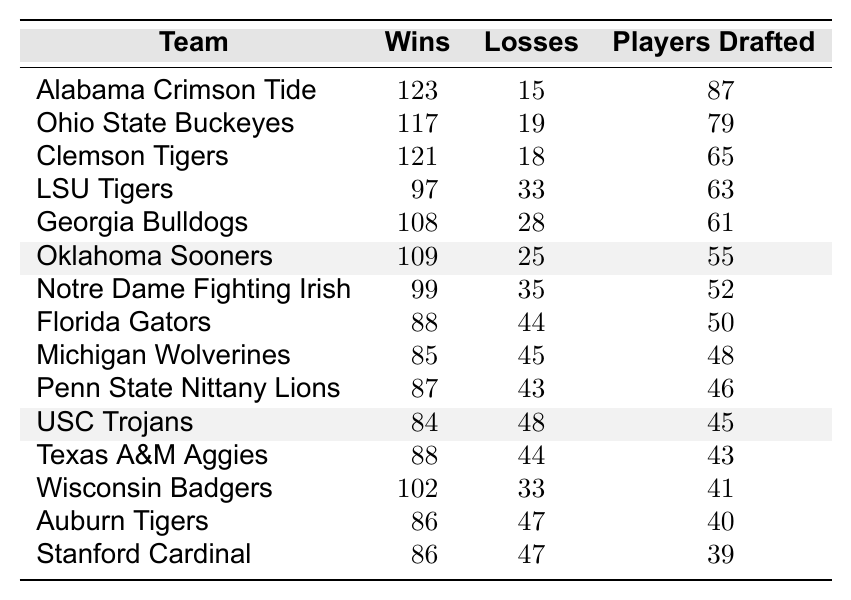What is the win-loss record for Alabama Crimson Tide? The win-loss record for Alabama Crimson Tide is listed in the table, showing a total of 123 wins and 15 losses.
Answer: 123-15 How many players were drafted from Oklahoma Sooners? The table indicates that Oklahoma Sooners had 55 players drafted to the NFL in the last decade.
Answer: 55 Which team has the most players drafted to the NFL? By comparing the drafted players' numbers in the table, Alabama Crimson Tide has the highest count with 87 players drafted.
Answer: Alabama Crimson Tide What is the total number of wins for all teams listed in the table combined? The total wins can be computed by adding the individual wins: 123 + 117 + 121 + 97 + 108 + 109 + 99 + 88 + 85 + 87 + 84 + 88 + 102 + 86 + 86 = 1471.
Answer: 1471 What is the average number of players drafted among the teams? To find the average, sum the number of players drafted: 87 + 79 + 65 + 63 + 61 + 55 + 52 + 50 + 48 + 46 + 45 + 43 + 41 + 40 + 39 = 748, then divide by the number of teams (15): 748/15 = 49.87.
Answer: 49.87 How many teams have more than 60 players drafted? A review of the drafted players shows that Alabama, Ohio State, Clemson, LSU, Georgia have more than 60 players, tallying up to 5 teams.
Answer: 5 Is it true that Michigan Wolverines have more wins than Texas A&M Aggies? Comparing the win-loss records: Michigan has 85 wins while Texas A&M has 88, so it’s false.
Answer: No Which team had the fewest losses from the provided data? By checking the losses column, Alabama Crimson Tide with 15 losses has the fewest compared to others in the list.
Answer: Alabama Crimson Tide What is the difference in drafted players between LSU Tigers and Georgia Bulldogs? The drafted players are 63 for LSU and 61 for Georgia; the difference is 63 - 61 = 2.
Answer: 2 How many teams have a win-loss record better than 100 wins and less than 20 losses? Observing the records, only Alabama (123-15), Ohio State (117-19), and Clemson (121-18) qualify, totaling 3 teams.
Answer: 3 